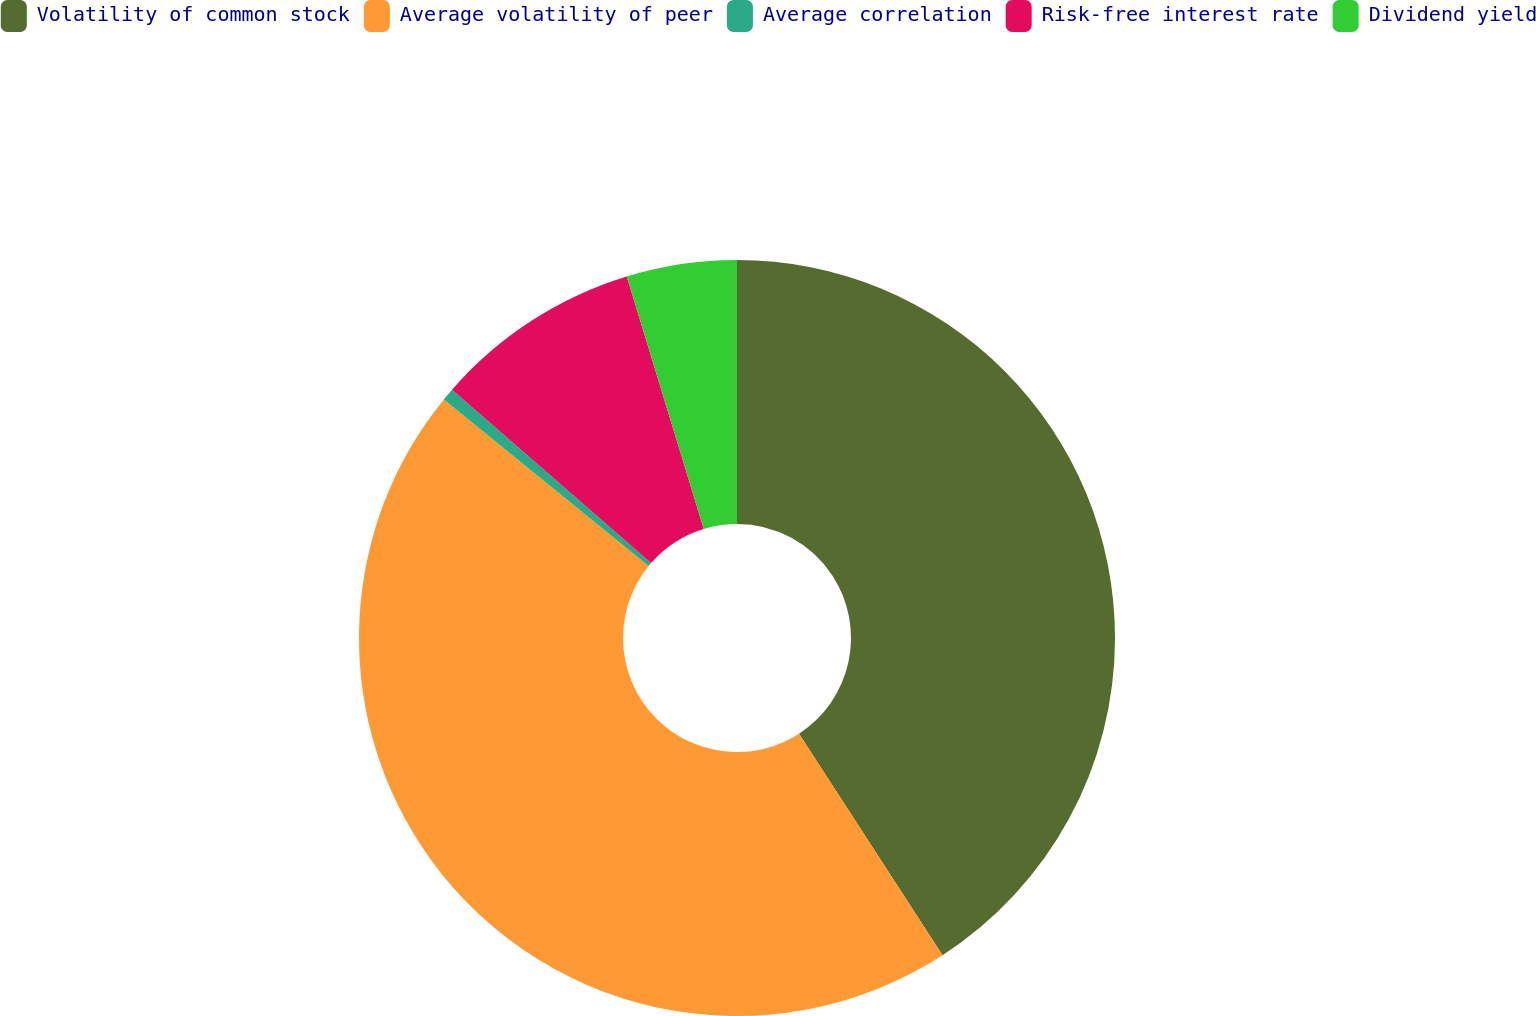<chart> <loc_0><loc_0><loc_500><loc_500><pie_chart><fcel>Volatility of common stock<fcel>Average volatility of peer<fcel>Average correlation<fcel>Risk-free interest rate<fcel>Dividend yield<nl><fcel>40.85%<fcel>45.02%<fcel>0.54%<fcel>8.88%<fcel>4.71%<nl></chart> 